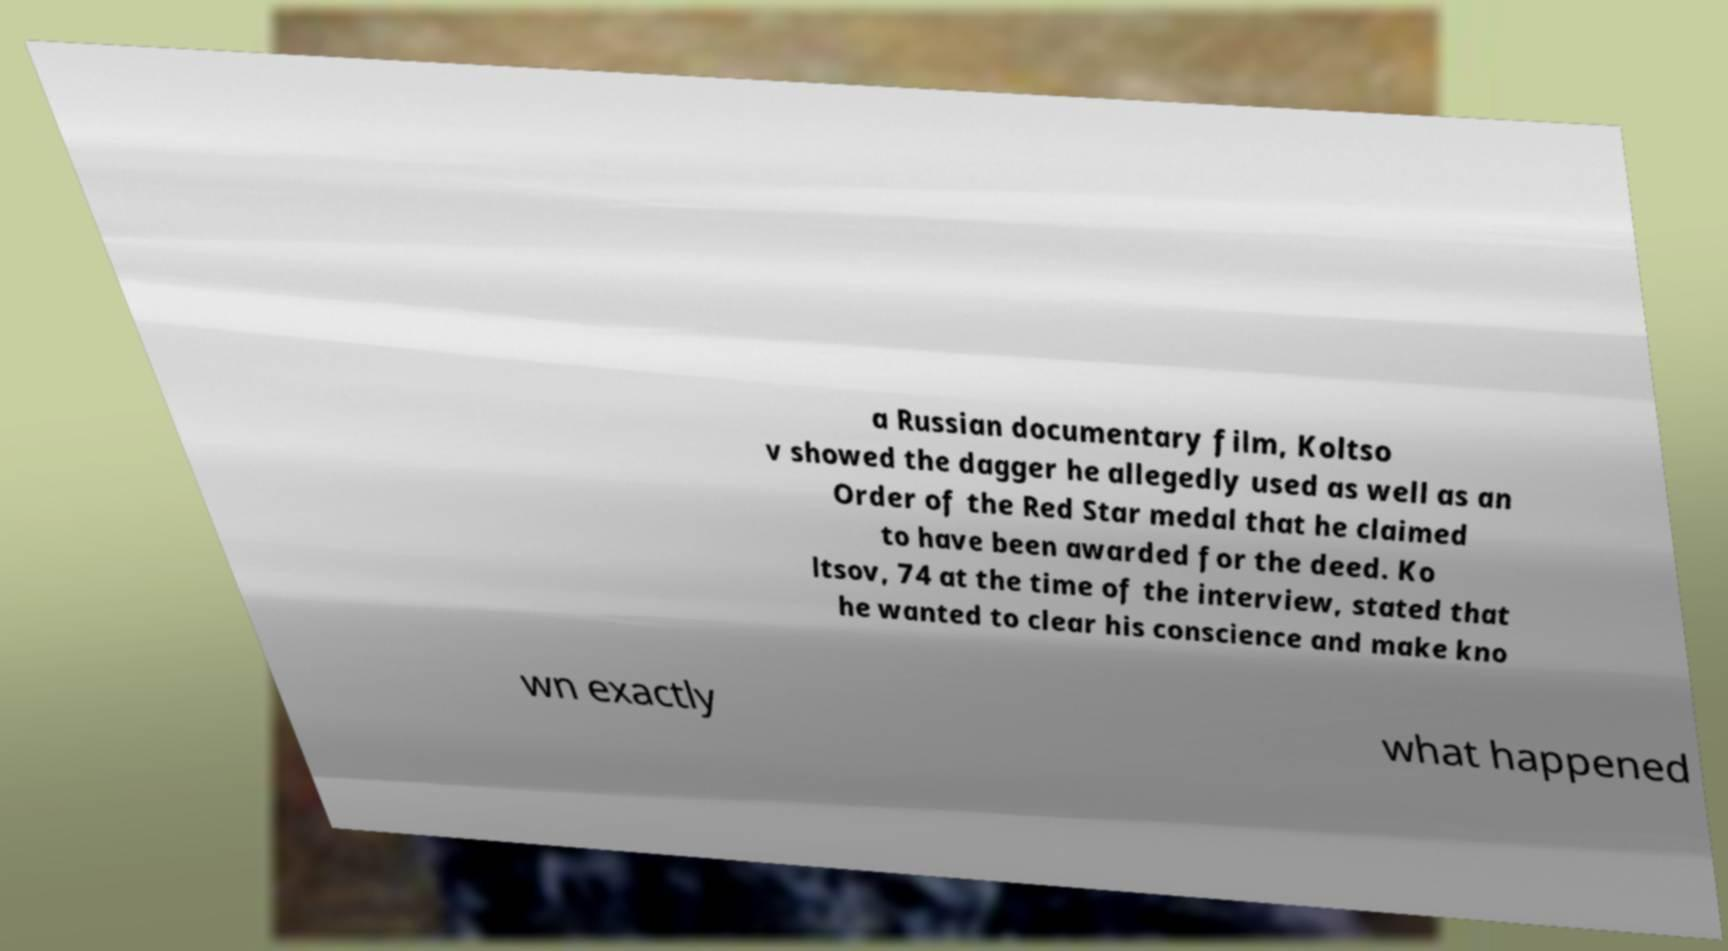For documentation purposes, I need the text within this image transcribed. Could you provide that? a Russian documentary film, Koltso v showed the dagger he allegedly used as well as an Order of the Red Star medal that he claimed to have been awarded for the deed. Ko ltsov, 74 at the time of the interview, stated that he wanted to clear his conscience and make kno wn exactly what happened 